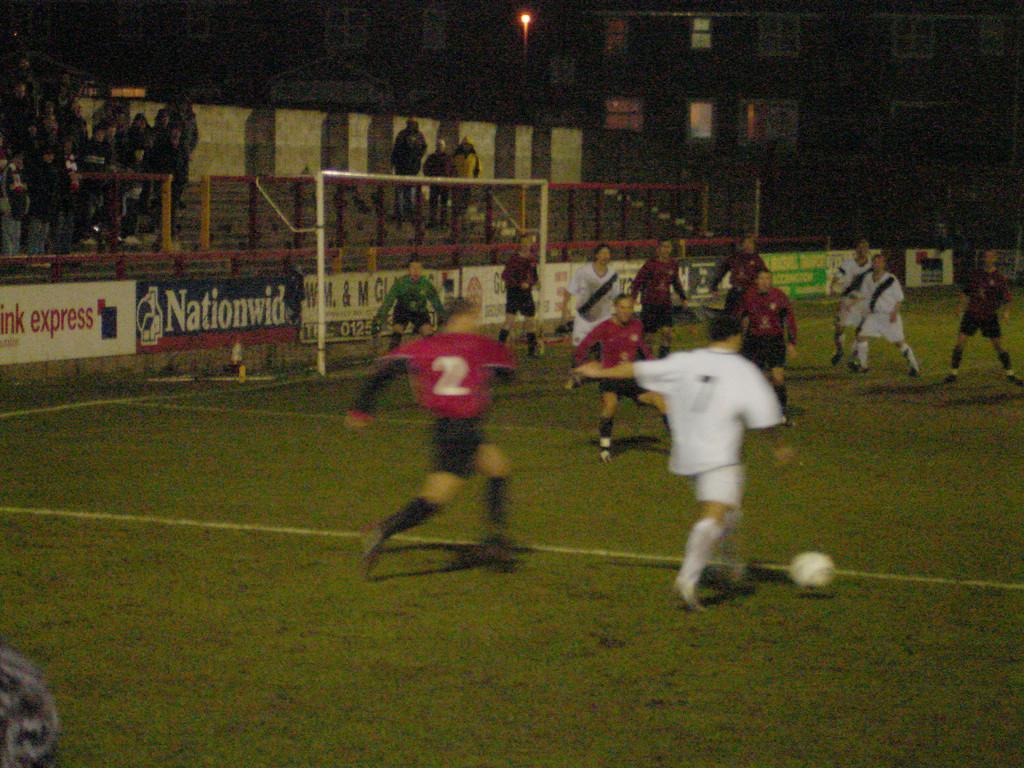Please provide a concise description of this image. In this image players are playing football on a ground, in the background there are boards and few people are standing. 